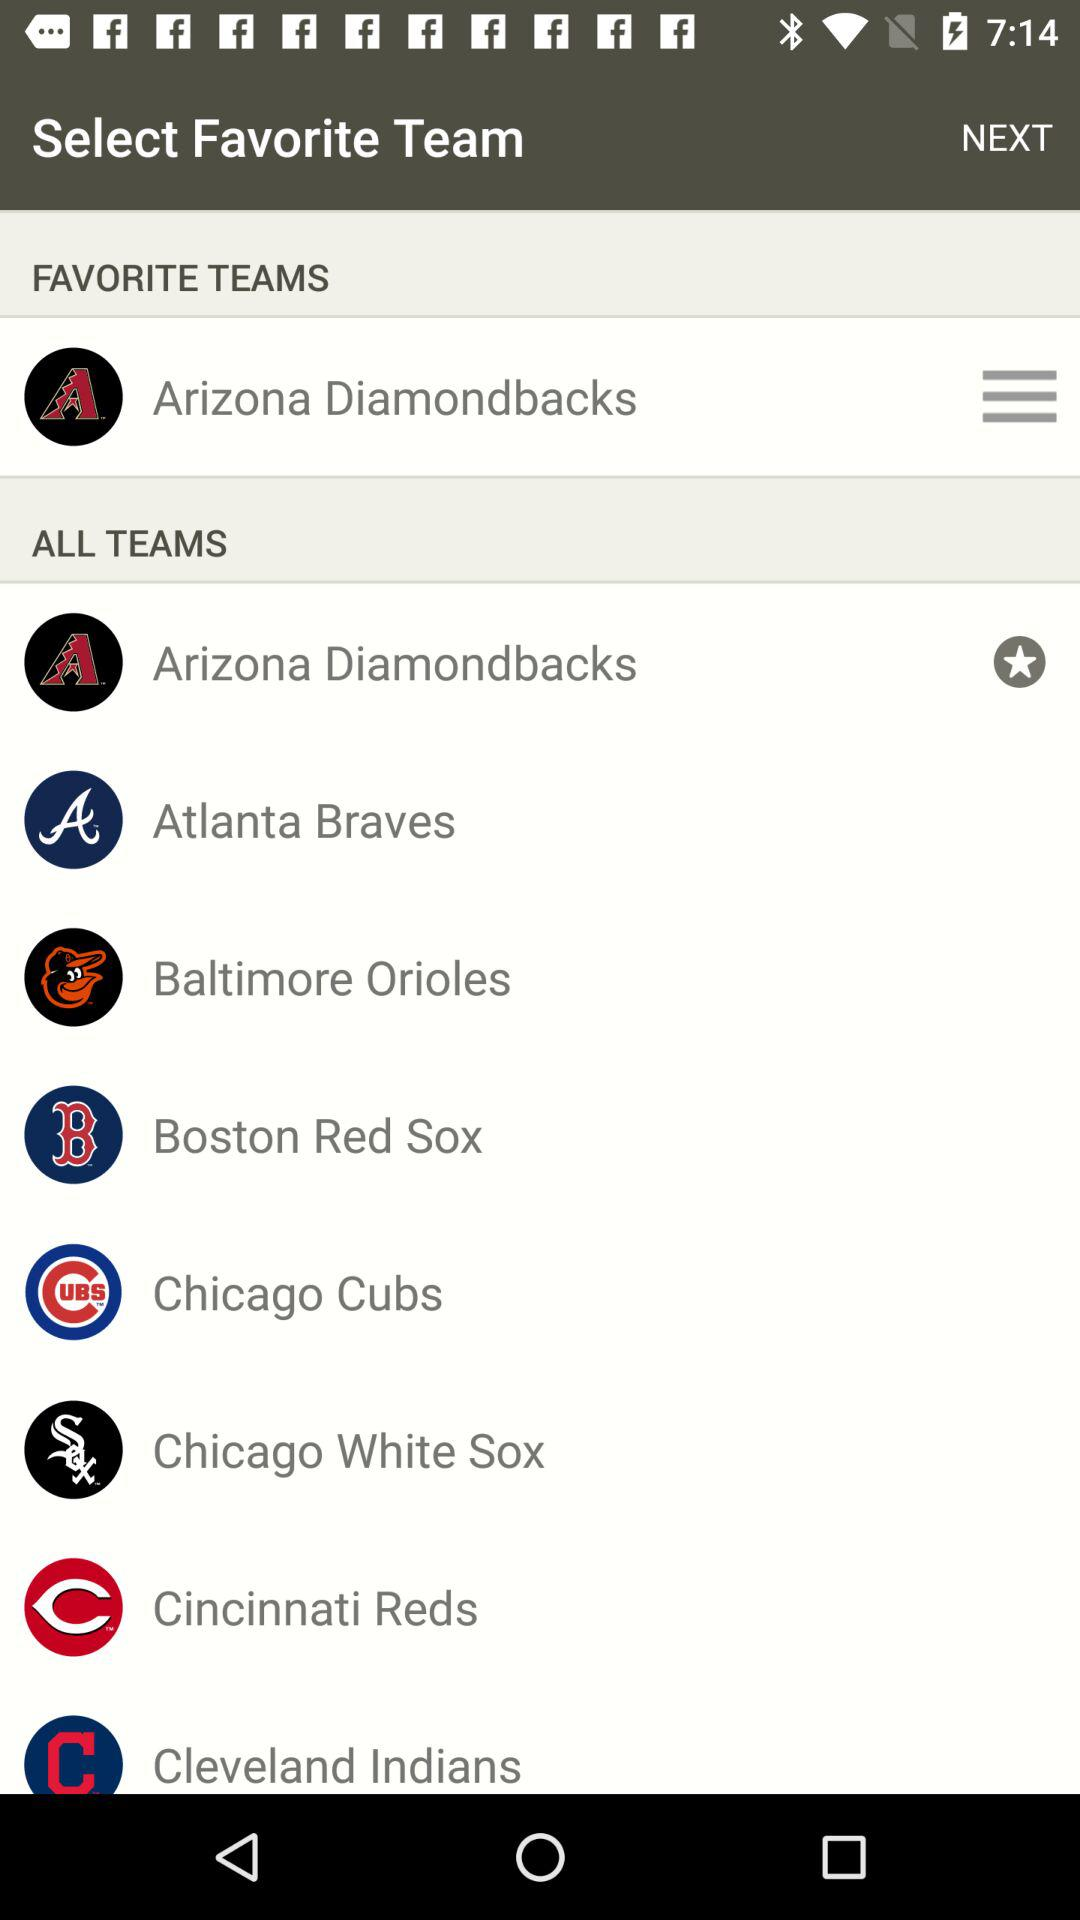Which is the winning team?
When the provided information is insufficient, respond with <no answer>. <no answer> 